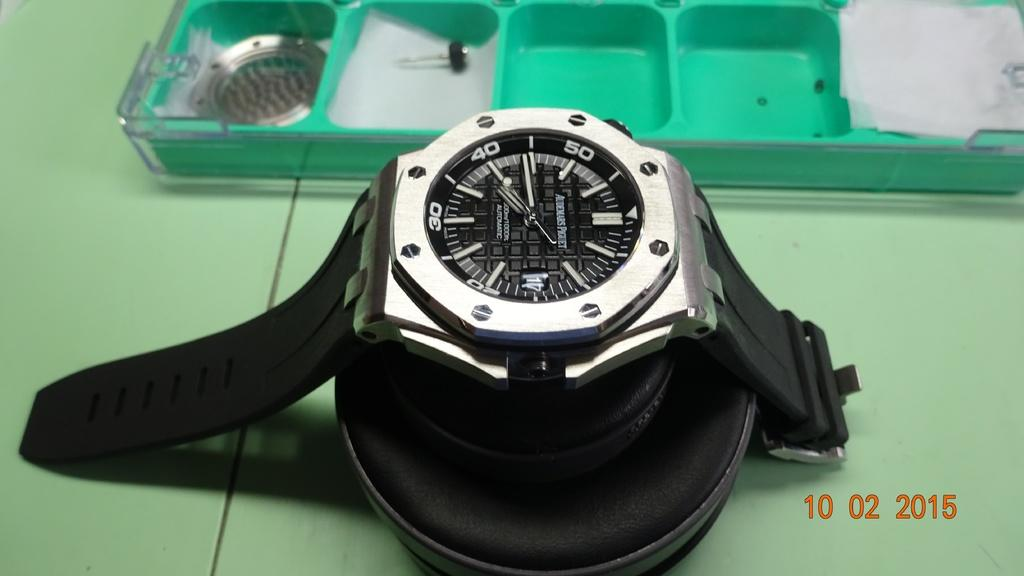<image>
Present a compact description of the photo's key features. a automatic anolog wrist watch set a 2:15 